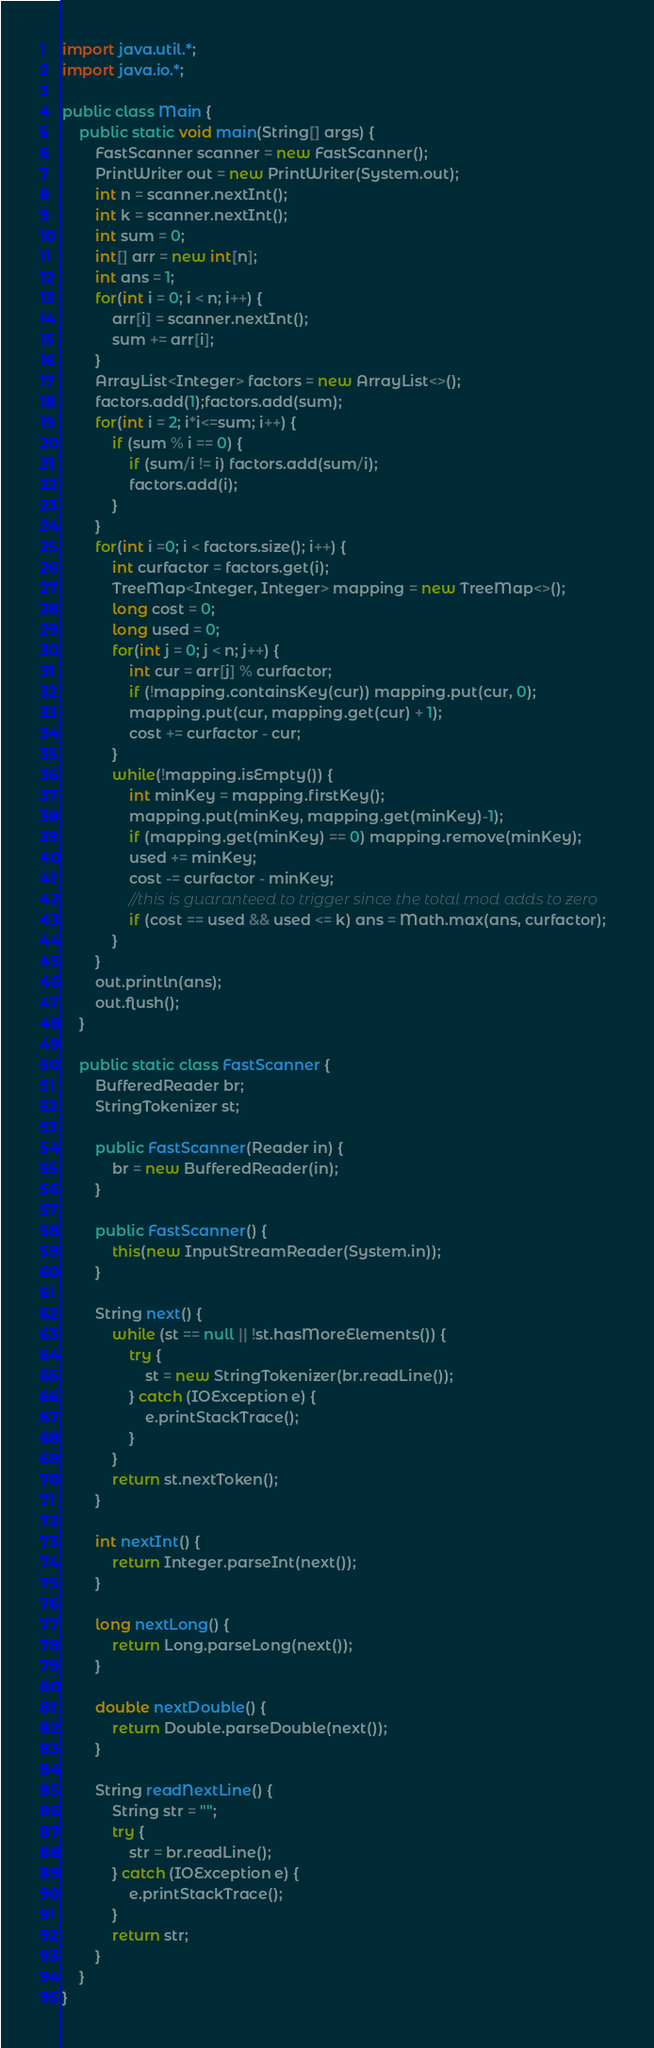Convert code to text. <code><loc_0><loc_0><loc_500><loc_500><_Java_>import java.util.*;
import java.io.*;

public class Main {
    public static void main(String[] args) {
        FastScanner scanner = new FastScanner();
        PrintWriter out = new PrintWriter(System.out);
        int n = scanner.nextInt();
        int k = scanner.nextInt();
        int sum = 0;
        int[] arr = new int[n];
        int ans = 1;
        for(int i = 0; i < n; i++) {
            arr[i] = scanner.nextInt();
            sum += arr[i];
        }
        ArrayList<Integer> factors = new ArrayList<>();
        factors.add(1);factors.add(sum);
        for(int i = 2; i*i<=sum; i++) {
            if (sum % i == 0) {
                if (sum/i != i) factors.add(sum/i);
                factors.add(i);
            }
        }
        for(int i =0; i < factors.size(); i++) {
            int curfactor = factors.get(i);
            TreeMap<Integer, Integer> mapping = new TreeMap<>();
            long cost = 0;
            long used = 0;
            for(int j = 0; j < n; j++) {
                int cur = arr[j] % curfactor;
                if (!mapping.containsKey(cur)) mapping.put(cur, 0);
                mapping.put(cur, mapping.get(cur) + 1);
                cost += curfactor - cur;
            }
            while(!mapping.isEmpty()) {
                int minKey = mapping.firstKey();
                mapping.put(minKey, mapping.get(minKey)-1);
                if (mapping.get(minKey) == 0) mapping.remove(minKey);
                used += minKey;
                cost -= curfactor - minKey;
                //this is guaranteed to trigger since the total mod adds to zero
                if (cost == used && used <= k) ans = Math.max(ans, curfactor);
            }
        }
        out.println(ans);
        out.flush();
    }
    
    public static class FastScanner {
        BufferedReader br;
        StringTokenizer st;
        
        public FastScanner(Reader in) {
            br = new BufferedReader(in);
        }
        
        public FastScanner() {
            this(new InputStreamReader(System.in));
        }
        
        String next() {
            while (st == null || !st.hasMoreElements()) {
                try {
                    st = new StringTokenizer(br.readLine());
                } catch (IOException e) {
                    e.printStackTrace();
                }
            }
            return st.nextToken();
        }
        
        int nextInt() {
            return Integer.parseInt(next());
        }
        
        long nextLong() {
            return Long.parseLong(next());
        }
        
        double nextDouble() {
            return Double.parseDouble(next());
        }
        
        String readNextLine() {
            String str = "";
            try {
                str = br.readLine();
            } catch (IOException e) {
                e.printStackTrace();
            }
            return str;
        }
    }
}
</code> 